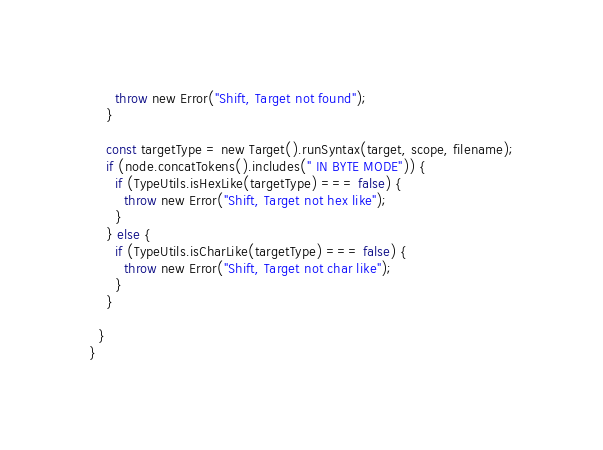<code> <loc_0><loc_0><loc_500><loc_500><_TypeScript_>      throw new Error("Shift, Target not found");
    }

    const targetType = new Target().runSyntax(target, scope, filename);
    if (node.concatTokens().includes(" IN BYTE MODE")) {
      if (TypeUtils.isHexLike(targetType) === false) {
        throw new Error("Shift, Target not hex like");
      }
    } else {
      if (TypeUtils.isCharLike(targetType) === false) {
        throw new Error("Shift, Target not char like");
      }
    }

  }
}</code> 